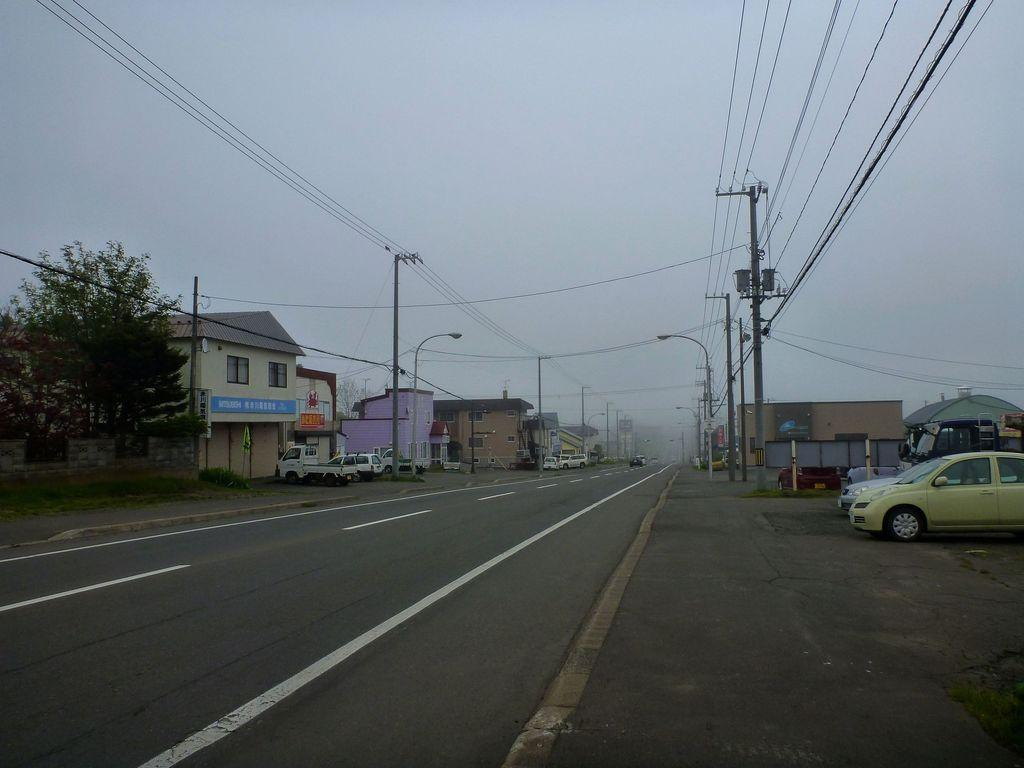What type of structures can be seen in the image? There are buildings in the image. What mode of transportation can be seen on the road in the image? Motor vehicles are present on the road in the image. What are the electric poles supporting in the image? Electric cables are present in the image, supported by the electric poles. What type of vegetation is visible in the image? Trees, grass, and shrubs are present in the image. What part of the natural environment is visible in the image? The sky is visible in the image. What event is taking place in the image involving the writer? There is no writer or event present in the image; it features buildings, motor vehicles, electric poles, electric cables, trees, grass, shrubs, and the sky. Is there any smoke visible in the image? There is no smoke present in the image. 